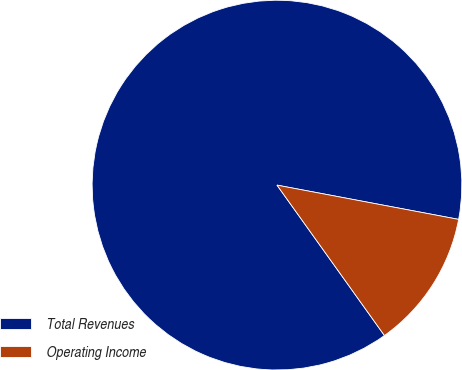Convert chart to OTSL. <chart><loc_0><loc_0><loc_500><loc_500><pie_chart><fcel>Total Revenues<fcel>Operating Income<nl><fcel>87.84%<fcel>12.16%<nl></chart> 